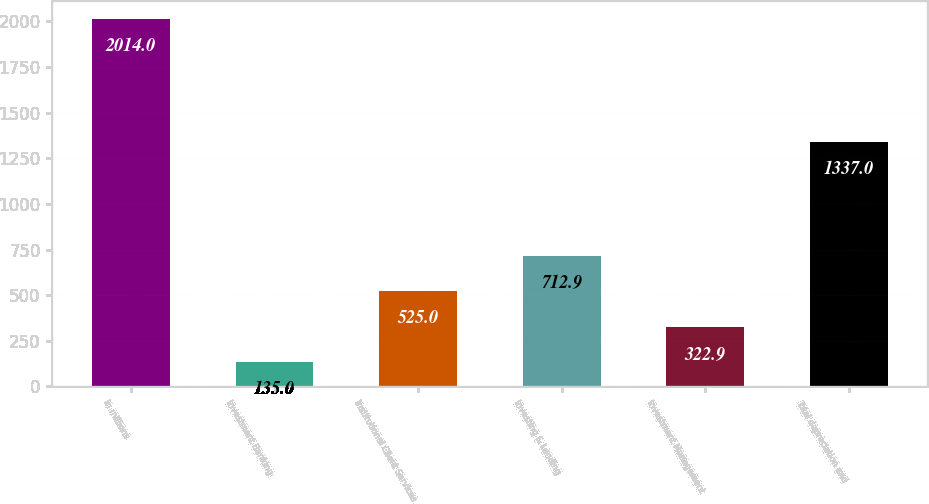Convert chart. <chart><loc_0><loc_0><loc_500><loc_500><bar_chart><fcel>in millions<fcel>Investment Banking<fcel>Institutional Client Services<fcel>Investing & Lending<fcel>Investment Management<fcel>Total depreciation and<nl><fcel>2014<fcel>135<fcel>525<fcel>712.9<fcel>322.9<fcel>1337<nl></chart> 